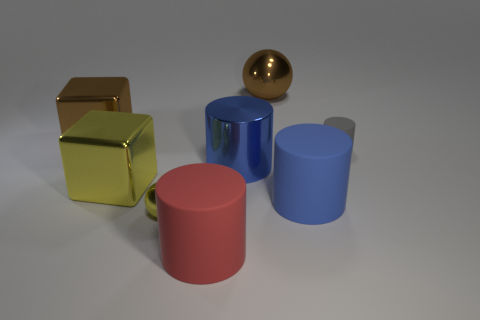There is a metallic block that is behind the tiny gray object; what number of tiny metal balls are on the right side of it? Beside the metallic block, which is positioned behind the tiny gray object, there is a single, tiny metal ball reflecting the environment with its shiny surface. 